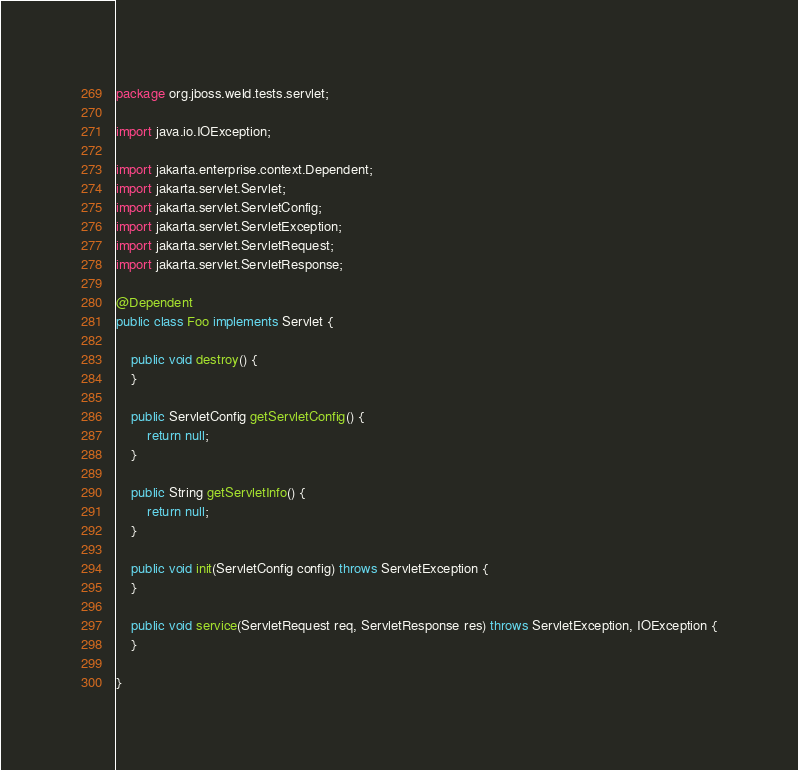<code> <loc_0><loc_0><loc_500><loc_500><_Java_>package org.jboss.weld.tests.servlet;

import java.io.IOException;

import jakarta.enterprise.context.Dependent;
import jakarta.servlet.Servlet;
import jakarta.servlet.ServletConfig;
import jakarta.servlet.ServletException;
import jakarta.servlet.ServletRequest;
import jakarta.servlet.ServletResponse;

@Dependent
public class Foo implements Servlet {

    public void destroy() {
    }

    public ServletConfig getServletConfig() {
        return null;
    }

    public String getServletInfo() {
        return null;
    }

    public void init(ServletConfig config) throws ServletException {
    }

    public void service(ServletRequest req, ServletResponse res) throws ServletException, IOException {
    }

}
</code> 